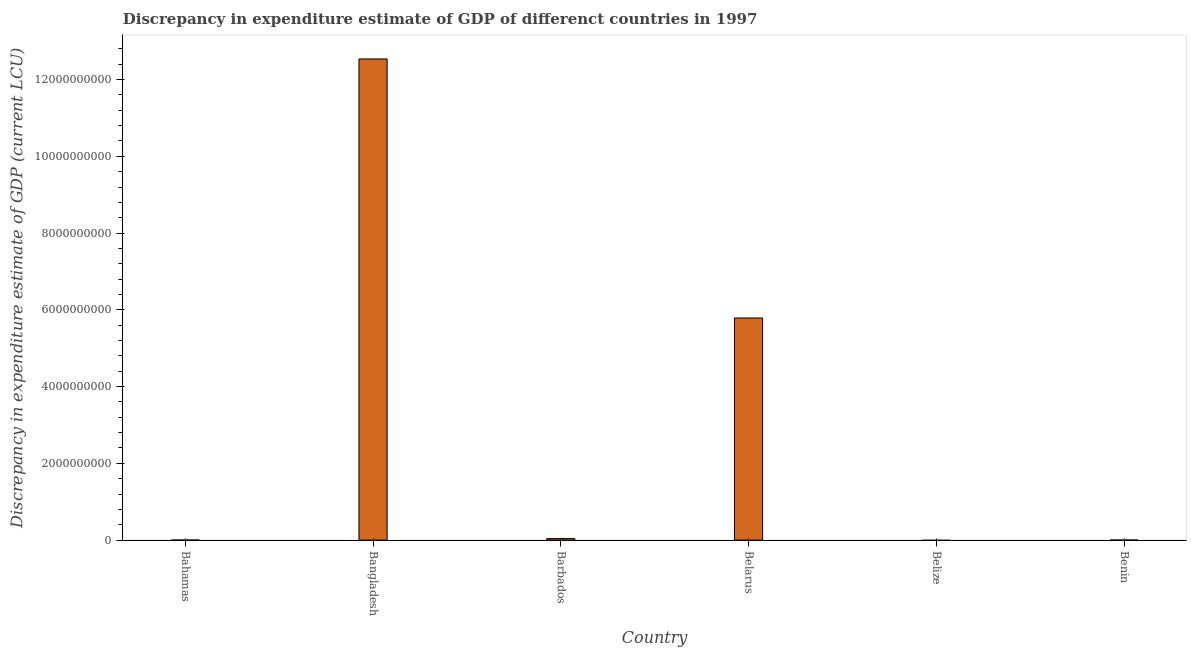Does the graph contain any zero values?
Your response must be concise. Yes. Does the graph contain grids?
Your answer should be very brief. No. What is the title of the graph?
Offer a very short reply. Discrepancy in expenditure estimate of GDP of differenct countries in 1997. What is the label or title of the X-axis?
Make the answer very short. Country. What is the label or title of the Y-axis?
Your response must be concise. Discrepancy in expenditure estimate of GDP (current LCU). Across all countries, what is the maximum discrepancy in expenditure estimate of gdp?
Give a very brief answer. 1.25e+1. In which country was the discrepancy in expenditure estimate of gdp maximum?
Provide a succinct answer. Bangladesh. What is the sum of the discrepancy in expenditure estimate of gdp?
Ensure brevity in your answer.  1.84e+1. What is the difference between the discrepancy in expenditure estimate of gdp in Bangladesh and Belarus?
Provide a short and direct response. 6.75e+09. What is the average discrepancy in expenditure estimate of gdp per country?
Provide a short and direct response. 3.06e+09. What is the median discrepancy in expenditure estimate of gdp?
Keep it short and to the point. 1.95e+07. In how many countries, is the discrepancy in expenditure estimate of gdp greater than 800000000 LCU?
Your answer should be compact. 2. What is the ratio of the discrepancy in expenditure estimate of gdp in Bangladesh to that in Belarus?
Make the answer very short. 2.17. Is the discrepancy in expenditure estimate of gdp in Barbados less than that in Belarus?
Your answer should be compact. Yes. Is the difference between the discrepancy in expenditure estimate of gdp in Barbados and Belarus greater than the difference between any two countries?
Your answer should be compact. No. What is the difference between the highest and the second highest discrepancy in expenditure estimate of gdp?
Offer a very short reply. 6.75e+09. What is the difference between the highest and the lowest discrepancy in expenditure estimate of gdp?
Give a very brief answer. 1.25e+1. What is the difference between two consecutive major ticks on the Y-axis?
Offer a very short reply. 2.00e+09. Are the values on the major ticks of Y-axis written in scientific E-notation?
Your answer should be very brief. No. What is the Discrepancy in expenditure estimate of GDP (current LCU) in Bangladesh?
Give a very brief answer. 1.25e+1. What is the Discrepancy in expenditure estimate of GDP (current LCU) of Barbados?
Provide a short and direct response. 3.90e+07. What is the Discrepancy in expenditure estimate of GDP (current LCU) in Belarus?
Provide a short and direct response. 5.79e+09. What is the Discrepancy in expenditure estimate of GDP (current LCU) of Belize?
Keep it short and to the point. 0. What is the Discrepancy in expenditure estimate of GDP (current LCU) of Benin?
Your answer should be compact. 100. What is the difference between the Discrepancy in expenditure estimate of GDP (current LCU) in Bangladesh and Barbados?
Give a very brief answer. 1.25e+1. What is the difference between the Discrepancy in expenditure estimate of GDP (current LCU) in Bangladesh and Belarus?
Provide a short and direct response. 6.75e+09. What is the difference between the Discrepancy in expenditure estimate of GDP (current LCU) in Bangladesh and Benin?
Your answer should be very brief. 1.25e+1. What is the difference between the Discrepancy in expenditure estimate of GDP (current LCU) in Barbados and Belarus?
Provide a short and direct response. -5.75e+09. What is the difference between the Discrepancy in expenditure estimate of GDP (current LCU) in Barbados and Benin?
Keep it short and to the point. 3.90e+07. What is the difference between the Discrepancy in expenditure estimate of GDP (current LCU) in Belarus and Benin?
Your answer should be compact. 5.79e+09. What is the ratio of the Discrepancy in expenditure estimate of GDP (current LCU) in Bangladesh to that in Barbados?
Your answer should be very brief. 321.46. What is the ratio of the Discrepancy in expenditure estimate of GDP (current LCU) in Bangladesh to that in Belarus?
Your answer should be very brief. 2.17. What is the ratio of the Discrepancy in expenditure estimate of GDP (current LCU) in Bangladesh to that in Benin?
Provide a short and direct response. 1.25e+08. What is the ratio of the Discrepancy in expenditure estimate of GDP (current LCU) in Barbados to that in Belarus?
Your response must be concise. 0.01. What is the ratio of the Discrepancy in expenditure estimate of GDP (current LCU) in Barbados to that in Benin?
Your answer should be very brief. 3.90e+05. What is the ratio of the Discrepancy in expenditure estimate of GDP (current LCU) in Belarus to that in Benin?
Offer a terse response. 5.79e+07. 